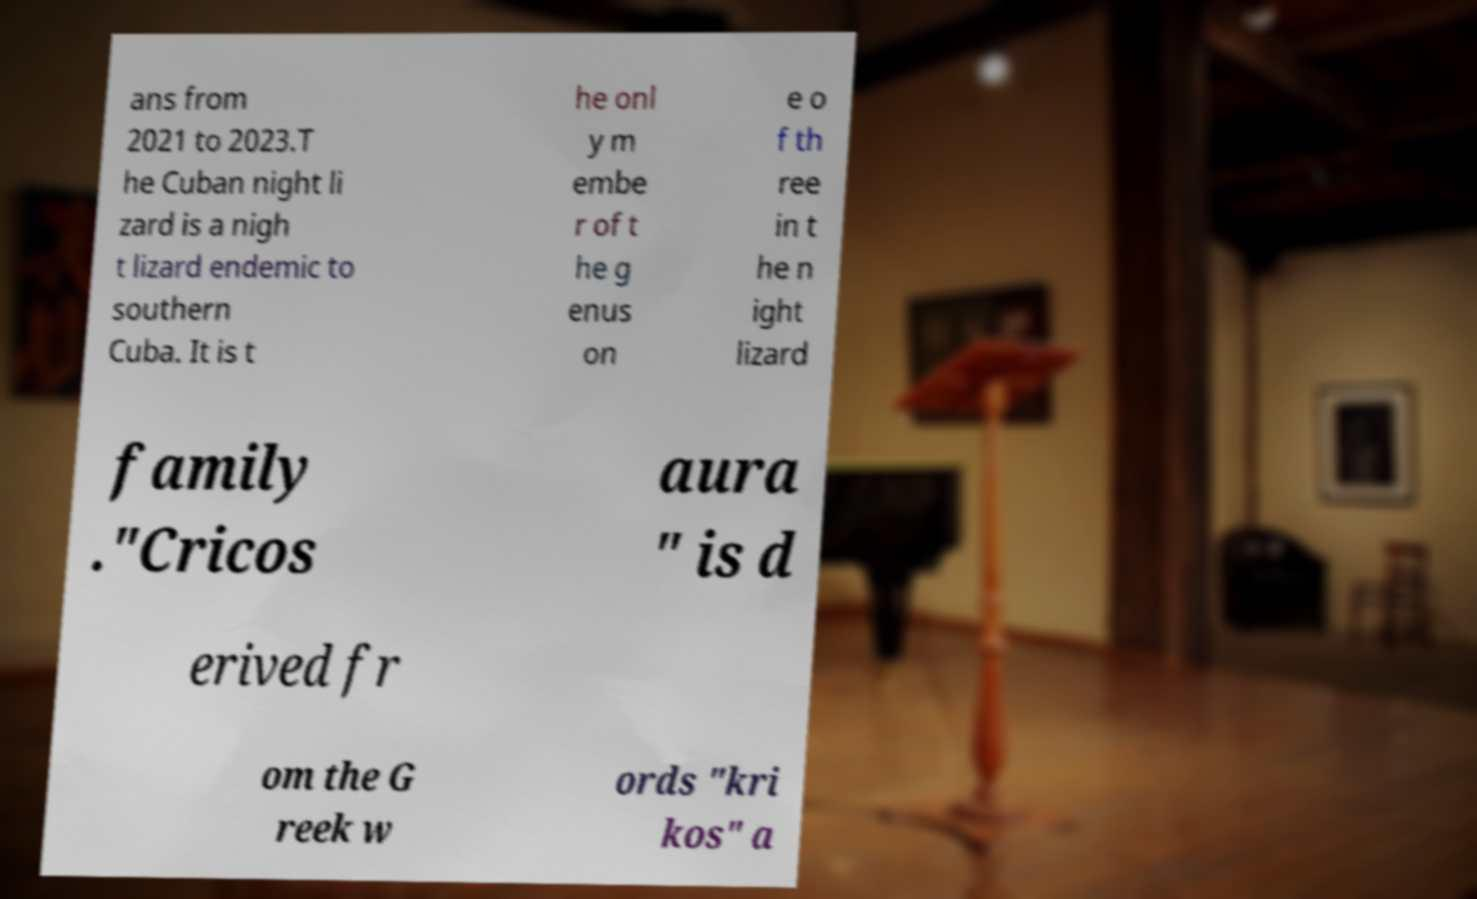I need the written content from this picture converted into text. Can you do that? ans from 2021 to 2023.T he Cuban night li zard is a nigh t lizard endemic to southern Cuba. It is t he onl y m embe r of t he g enus on e o f th ree in t he n ight lizard family ."Cricos aura " is d erived fr om the G reek w ords "kri kos" a 